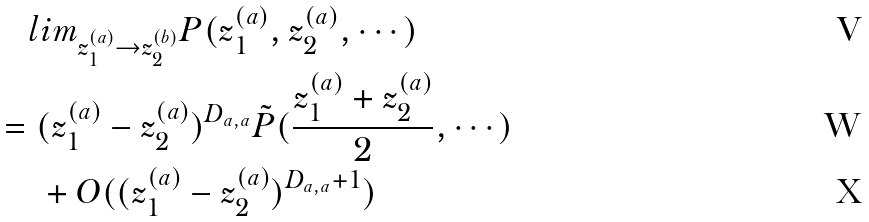Convert formula to latex. <formula><loc_0><loc_0><loc_500><loc_500>& \quad l i m _ { z _ { 1 } ^ { ( a ) } \rightarrow z _ { 2 } ^ { ( b ) } } P ( z _ { 1 } ^ { ( a ) } , z _ { 2 } ^ { ( a ) } , \cdots ) \\ & = ( z _ { 1 } ^ { ( a ) } - z _ { 2 } ^ { ( a ) } ) ^ { D _ { a , a } } \tilde { P } ( \frac { z _ { 1 } ^ { ( a ) } + z _ { 2 } ^ { ( a ) } } { 2 } , \cdots ) \\ & \quad \ + O ( ( z _ { 1 } ^ { ( a ) } - z _ { 2 } ^ { ( a ) } ) ^ { D _ { a , a } + 1 } )</formula> 